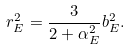<formula> <loc_0><loc_0><loc_500><loc_500>r ^ { 2 } _ { E } = \frac { 3 } { 2 + \alpha ^ { 2 } _ { E } } b _ { E } ^ { 2 } .</formula> 